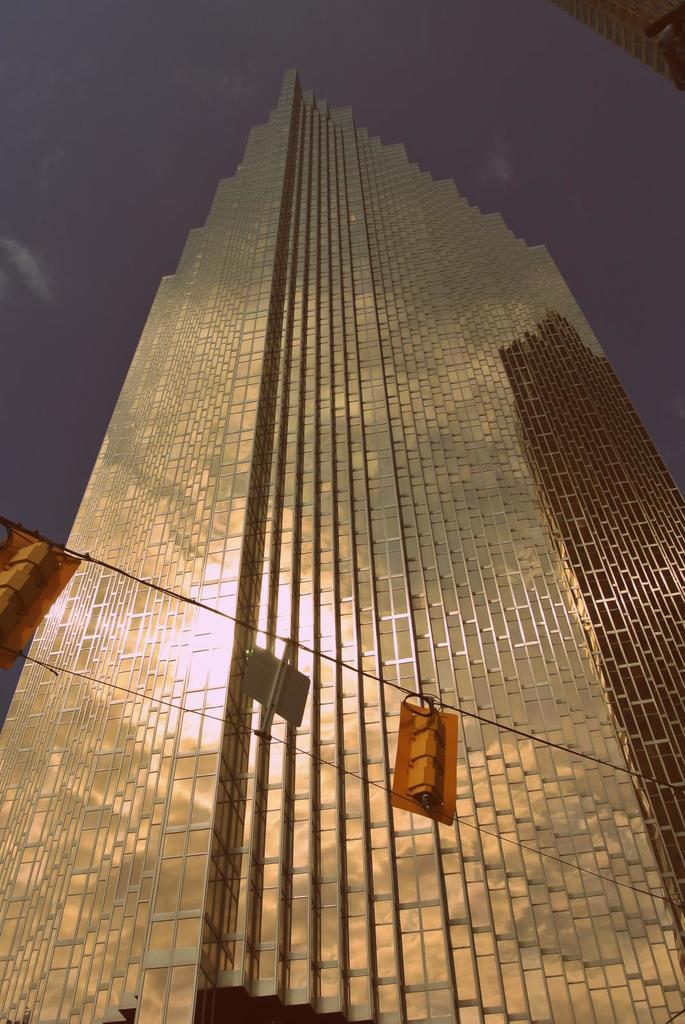What is the main structure in the center of the image? There is a building in the center of the image. What else can be seen in the image besides the building? Wires are visible in the image, along with objects associated with the wires. What is visible at the top of the image? The sky is visible at the top of the image. What type of cord is connected to the box on the wall in the image? There is no box or wall present in the image; it only features a building and wires. 